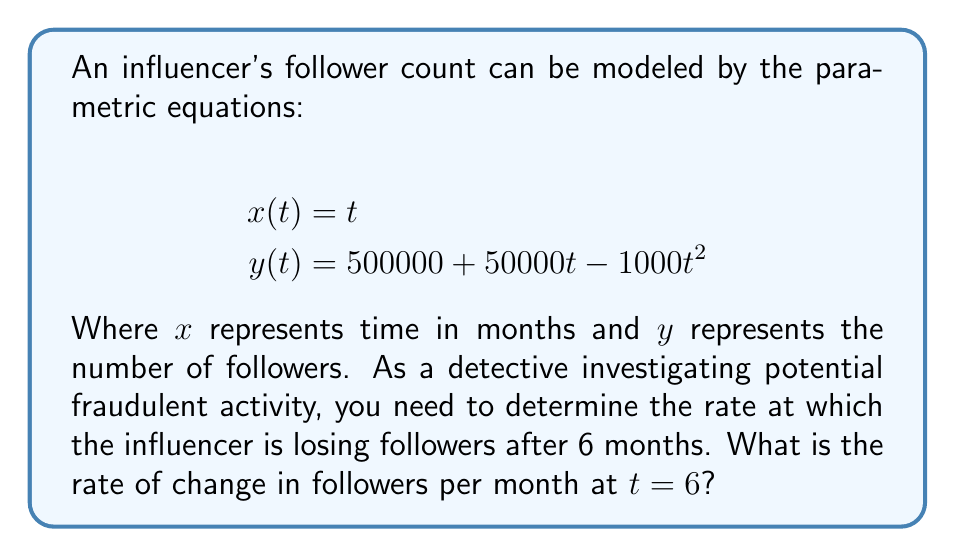Solve this math problem. To solve this problem, we need to find the rate of change of $y$ with respect to $x$ at $t = 6$. This can be done using the following steps:

1) First, we need to find $\frac{dy}{dt}$ and $\frac{dx}{dt}$:

   $$\frac{dy}{dt} = 50000 - 2000t$$
   $$\frac{dx}{dt} = 1$$

2) The rate of change of $y$ with respect to $x$ is given by:

   $$\frac{dy}{dx} = \frac{dy/dt}{dx/dt} = 50000 - 2000t$$

3) Now, we need to evaluate this at $t = 6$:

   $$\frac{dy}{dx}\bigg|_{t=6} = 50000 - 2000(6) = 50000 - 12000 = 38000$$

4) The negative of this value gives us the rate at which the influencer is losing followers:

   $$-\frac{dy}{dx}\bigg|_{t=6} = -38000$$

Therefore, after 6 months, the influencer is losing followers at a rate of 38,000 followers per month.
Answer: $-38000$ followers per month 